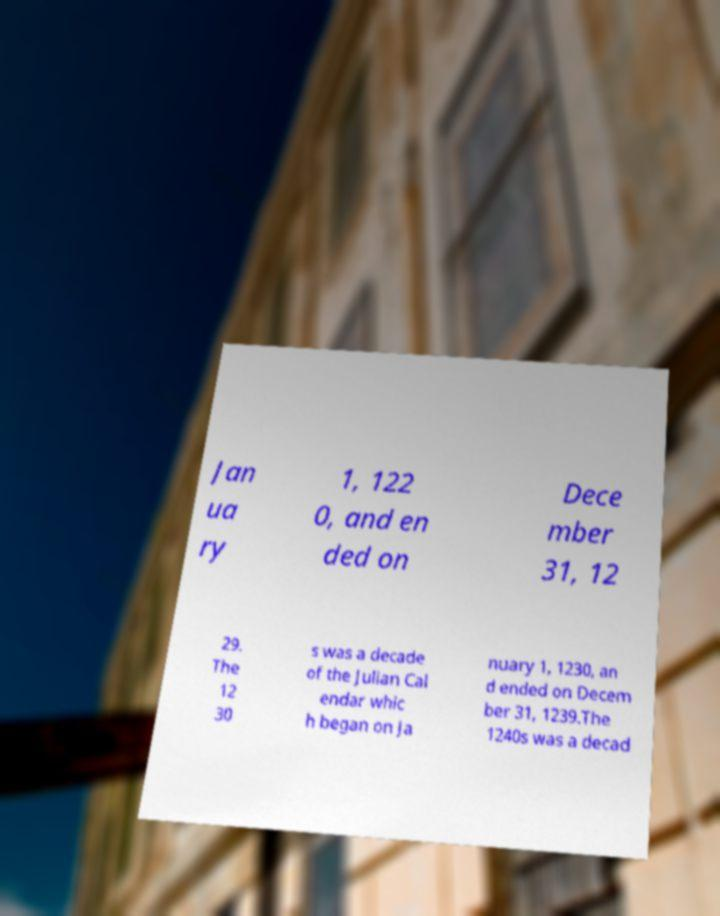Can you accurately transcribe the text from the provided image for me? Jan ua ry 1, 122 0, and en ded on Dece mber 31, 12 29. The 12 30 s was a decade of the Julian Cal endar whic h began on Ja nuary 1, 1230, an d ended on Decem ber 31, 1239.The 1240s was a decad 